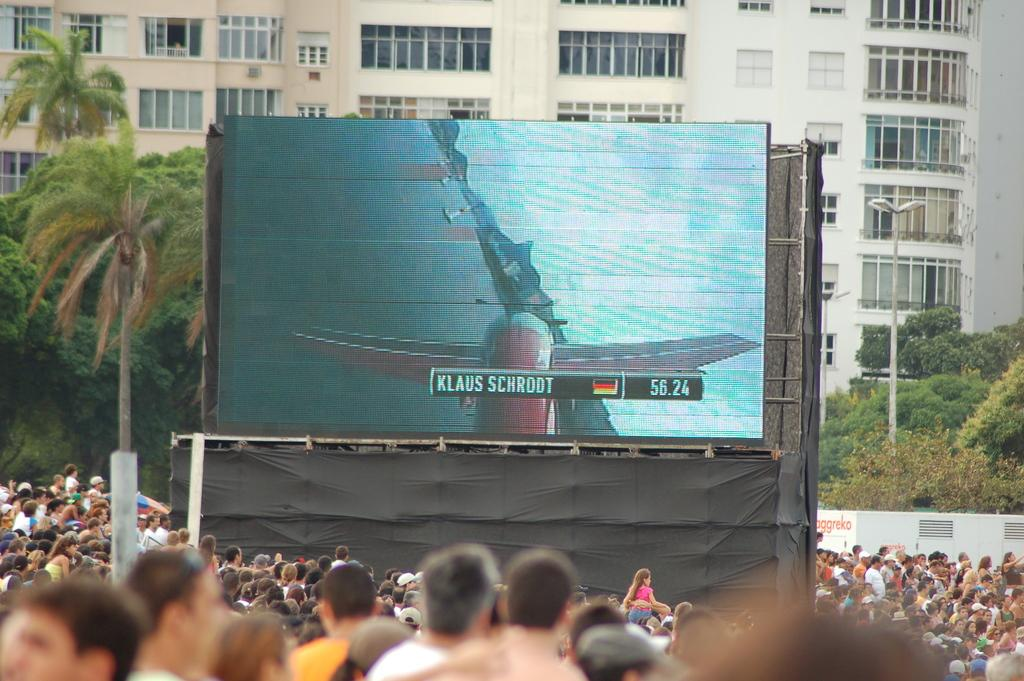What is the main subject of the image? The main subject of the image is a group of people. Where are the people located in the image? The group of people is located at the bottom of the image and on the left side. What is the group of people smashing in space in the image? There is no group of people smashing anything in space in the image; the image only shows a group of people located at the bottom and on the left side. 